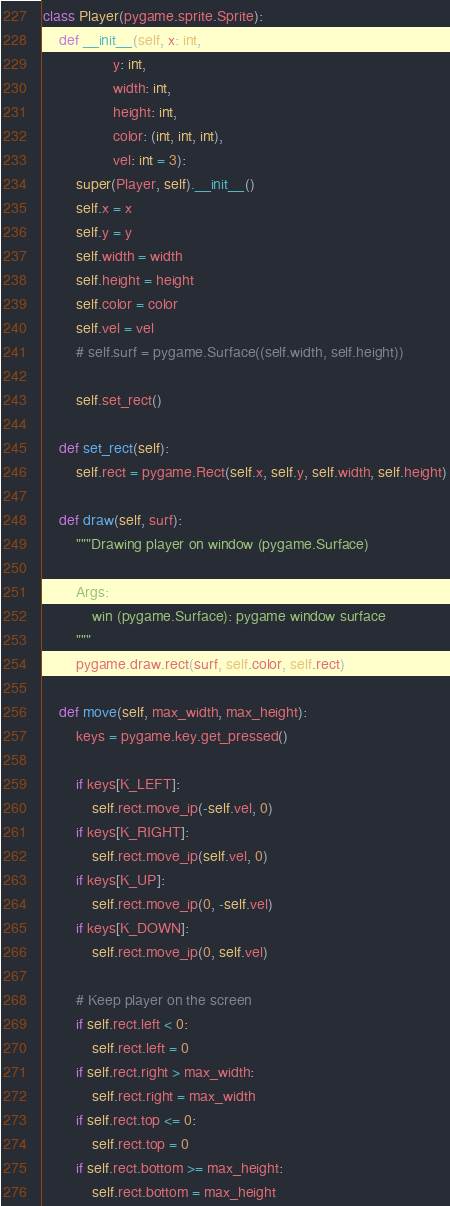<code> <loc_0><loc_0><loc_500><loc_500><_Python_>

class Player(pygame.sprite.Sprite):
    def __init__(self, x: int,
                 y: int,
                 width: int,
                 height: int,
                 color: (int, int, int),
                 vel: int = 3):
        super(Player, self).__init__()
        self.x = x
        self.y = y
        self.width = width
        self.height = height
        self.color = color
        self.vel = vel
        # self.surf = pygame.Surface((self.width, self.height))

        self.set_rect()

    def set_rect(self):
        self.rect = pygame.Rect(self.x, self.y, self.width, self.height)

    def draw(self, surf):
        """Drawing player on window (pygame.Surface)

        Args:
            win (pygame.Surface): pygame window surface
        """
        pygame.draw.rect(surf, self.color, self.rect)

    def move(self, max_width, max_height):
        keys = pygame.key.get_pressed()

        if keys[K_LEFT]:
            self.rect.move_ip(-self.vel, 0)
        if keys[K_RIGHT]:
            self.rect.move_ip(self.vel, 0)
        if keys[K_UP]:
            self.rect.move_ip(0, -self.vel)
        if keys[K_DOWN]:
            self.rect.move_ip(0, self.vel)

        # Keep player on the screen
        if self.rect.left < 0:
            self.rect.left = 0
        if self.rect.right > max_width:
            self.rect.right = max_width
        if self.rect.top <= 0:
            self.rect.top = 0
        if self.rect.bottom >= max_height:
            self.rect.bottom = max_height
</code> 